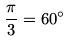<formula> <loc_0><loc_0><loc_500><loc_500>\frac { \pi } { 3 } = 6 0 ^ { \circ }</formula> 